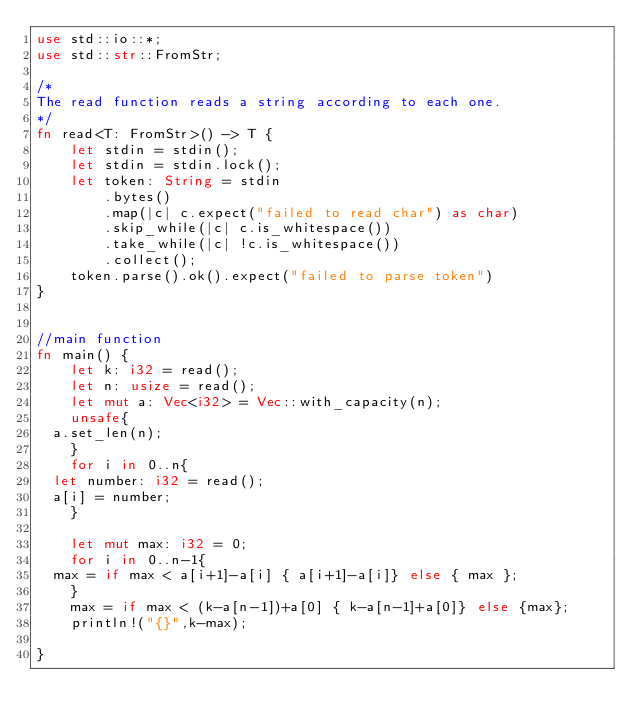Convert code to text. <code><loc_0><loc_0><loc_500><loc_500><_Rust_>use std::io::*;
use std::str::FromStr;
 
/* 
The read function reads a string according to each one. 
*/
fn read<T: FromStr>() -> T {
    let stdin = stdin();
    let stdin = stdin.lock();
    let token: String = stdin
        .bytes()
        .map(|c| c.expect("failed to read char") as char) 
        .skip_while(|c| c.is_whitespace())
        .take_while(|c| !c.is_whitespace())
        .collect();
    token.parse().ok().expect("failed to parse token")
}


//main function
fn main() {
    let k: i32 = read();
    let n: usize = read();
    let mut a: Vec<i32> = Vec::with_capacity(n);
    unsafe{
	a.set_len(n);
    }
    for i in 0..n{
	let number: i32 = read();
	a[i] = number;
    }

    let mut max: i32 = 0;
    for i in 0..n-1{
	max = if max < a[i+1]-a[i] { a[i+1]-a[i]} else { max };
    }
    max = if max < (k-a[n-1])+a[0] { k-a[n-1]+a[0]} else {max}; 
    println!("{}",k-max);
    
}
</code> 